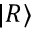Convert formula to latex. <formula><loc_0><loc_0><loc_500><loc_500>| R \rangle</formula> 